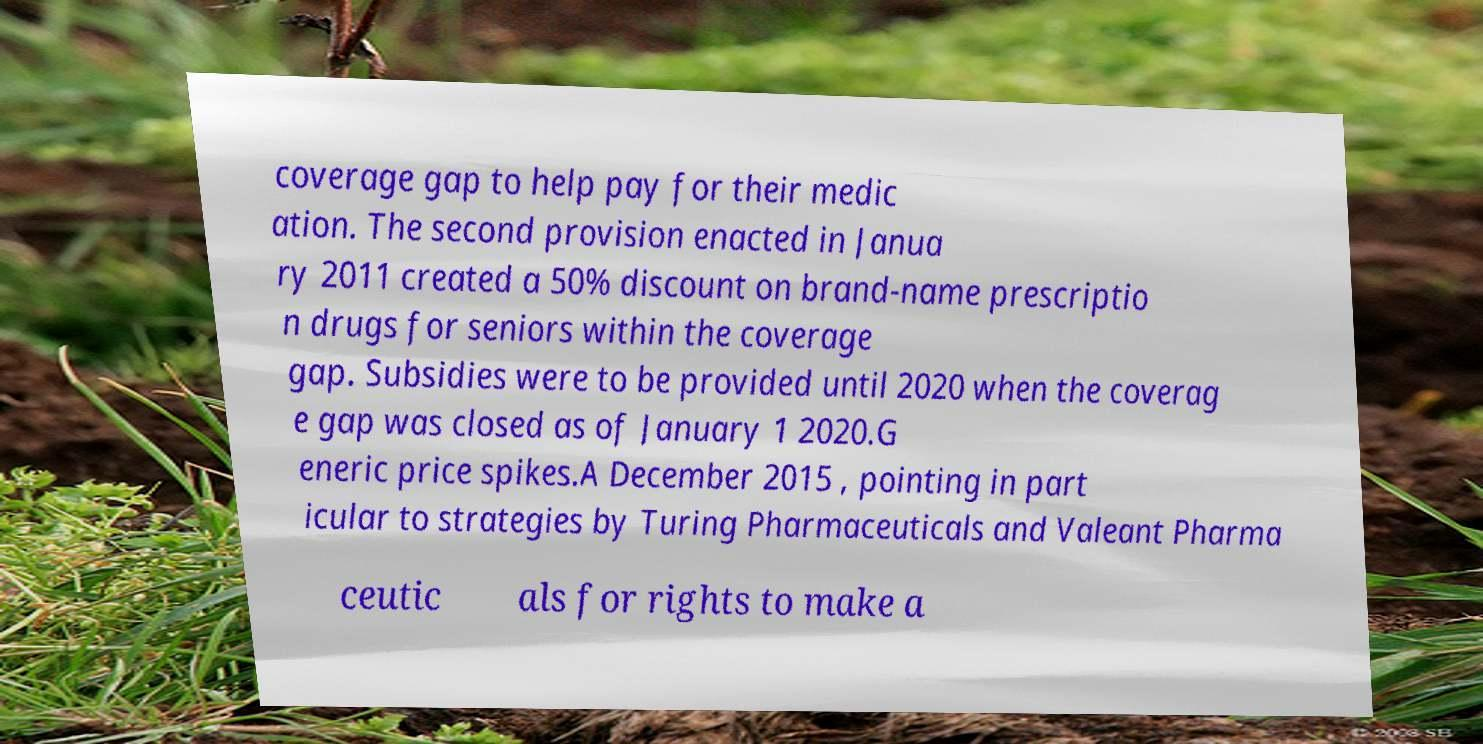Please identify and transcribe the text found in this image. coverage gap to help pay for their medic ation. The second provision enacted in Janua ry 2011 created a 50% discount on brand-name prescriptio n drugs for seniors within the coverage gap. Subsidies were to be provided until 2020 when the coverag e gap was closed as of January 1 2020.G eneric price spikes.A December 2015 , pointing in part icular to strategies by Turing Pharmaceuticals and Valeant Pharma ceutic als for rights to make a 